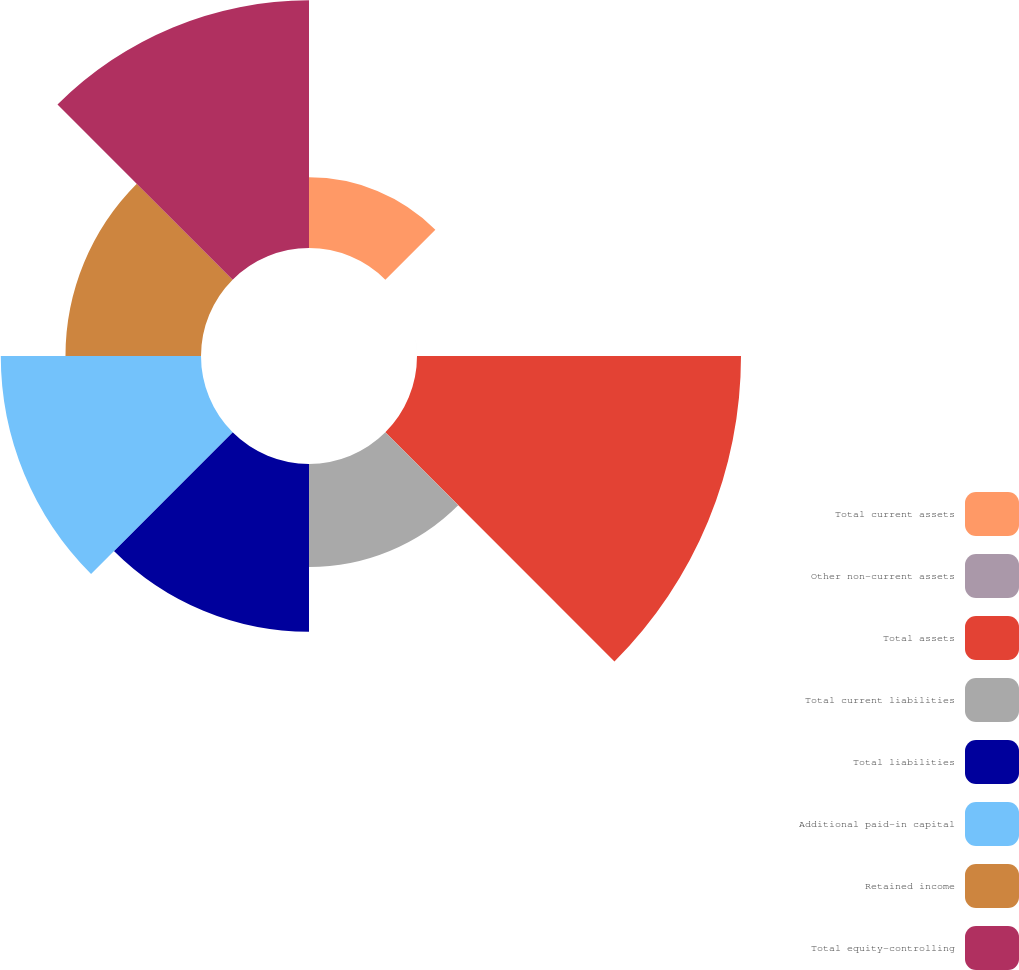<chart> <loc_0><loc_0><loc_500><loc_500><pie_chart><fcel>Total current assets<fcel>Other non-current assets<fcel>Total assets<fcel>Total current liabilities<fcel>Total liabilities<fcel>Additional paid-in capital<fcel>Retained income<fcel>Total equity-controlling<nl><fcel>5.66%<fcel>0.0%<fcel>25.94%<fcel>8.25%<fcel>13.44%<fcel>16.03%<fcel>10.85%<fcel>19.83%<nl></chart> 